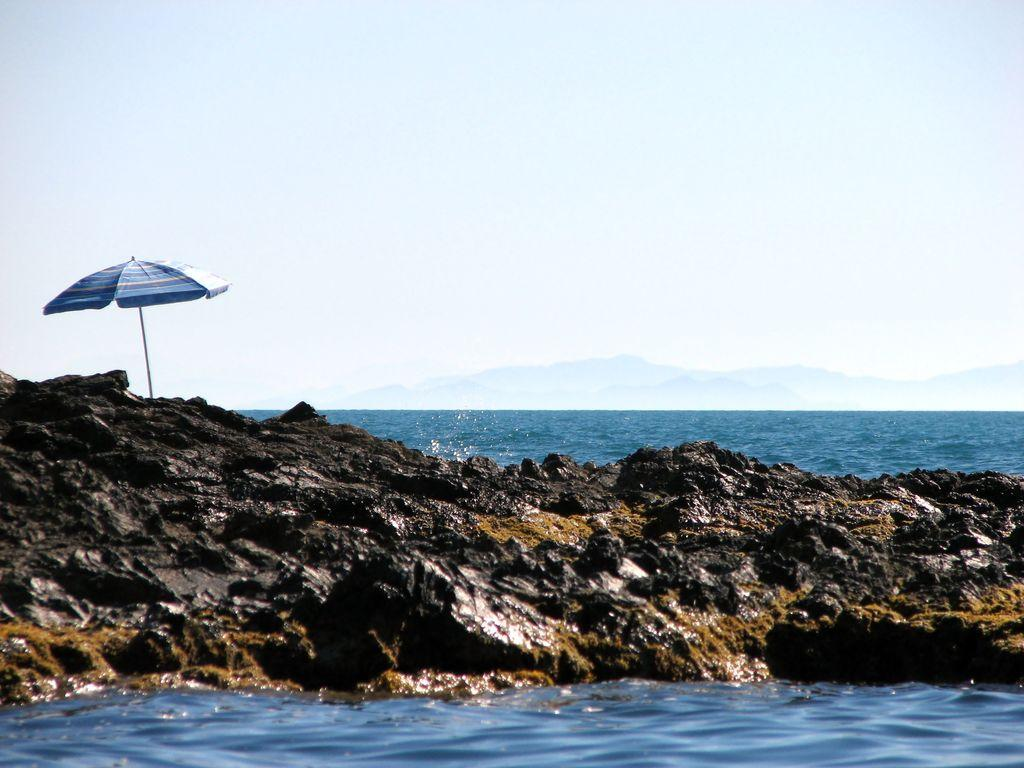What object is located on the left side of the image? There is a parasol on the left side of the image. What can be seen in the center of the image? There are rocks in the center of the image. What type of natural feature is visible in the background of the image? There is a sea in the background of the image. What other natural feature can be seen in the background of the image? There is a hill in the background of the image. What part of the sky is visible in the background of the image? The sky is visible in the background of the image. What type of decision can be seen being made in the image? There is no decision-making process visible in the image; it features a parasol, rocks, a sea, a hill, and the sky. What type of garden is present in the image? There is no garden present in the image; it features a parasol, rocks, a sea, a hill, and the sky. 